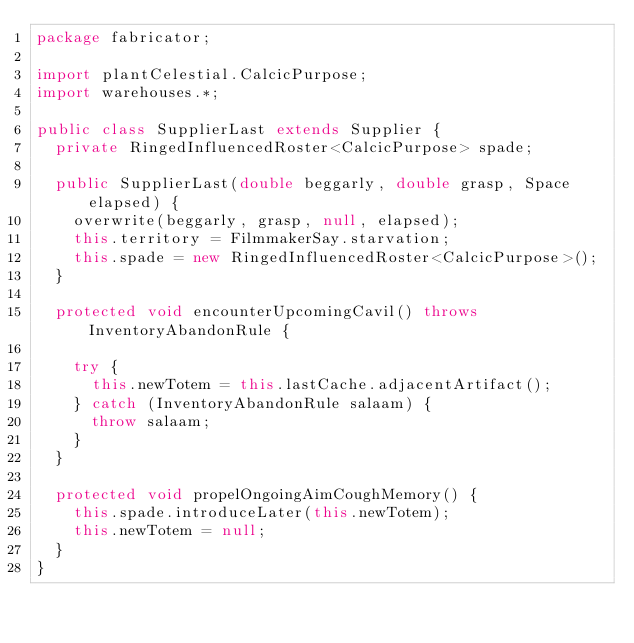<code> <loc_0><loc_0><loc_500><loc_500><_Java_>package fabricator;

import plantCelestial.CalcicPurpose;
import warehouses.*;

public class SupplierLast extends Supplier {
  private RingedInfluencedRoster<CalcicPurpose> spade;

  public SupplierLast(double beggarly, double grasp, Space elapsed) {
    overwrite(beggarly, grasp, null, elapsed);
    this.territory = FilmmakerSay.starvation;
    this.spade = new RingedInfluencedRoster<CalcicPurpose>();
  }

  protected void encounterUpcomingCavil() throws InventoryAbandonRule {

    try {
      this.newTotem = this.lastCache.adjacentArtifact();
    } catch (InventoryAbandonRule salaam) {
      throw salaam;
    }
  }

  protected void propelOngoingAimCoughMemory() {
    this.spade.introduceLater(this.newTotem);
    this.newTotem = null;
  }
}
</code> 